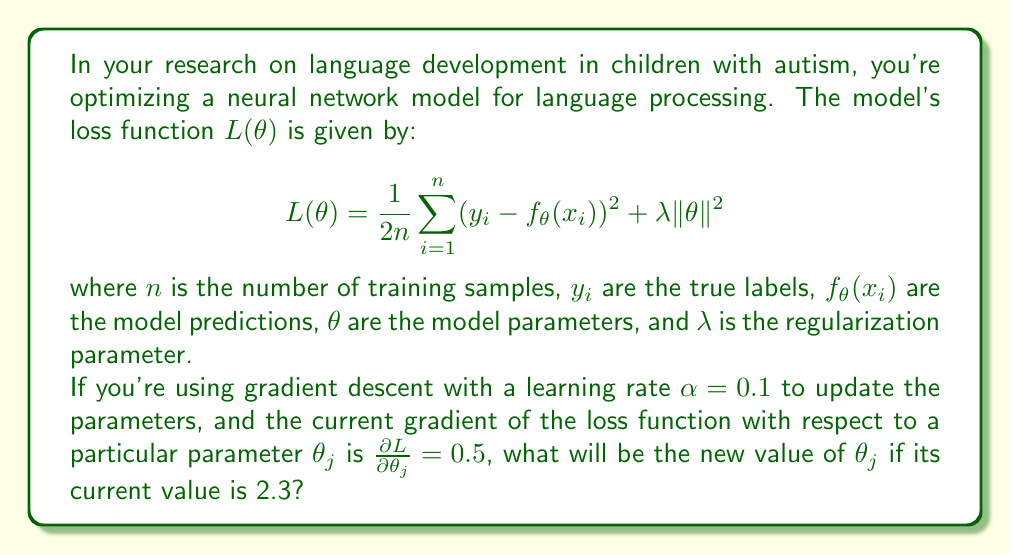What is the answer to this math problem? Let's approach this step-by-step:

1) In gradient descent, we update parameters using the formula:

   $$\theta_j^{new} = \theta_j^{old} - \alpha \frac{\partial L}{\partial \theta_j}$$

2) We're given:
   - Learning rate $\alpha = 0.1$
   - Current gradient $\frac{\partial L}{\partial \theta_j} = 0.5$
   - Current value of $\theta_j = 2.3$

3) Let's substitute these values into the update formula:

   $$\theta_j^{new} = 2.3 - 0.1 \cdot 0.5$$

4) Simplify:
   $$\theta_j^{new} = 2.3 - 0.05$$

5) Calculate the final result:
   $$\theta_j^{new} = 2.25$$

Therefore, after this gradient descent step, the new value of $\theta_j$ will be 2.25.
Answer: 2.25 